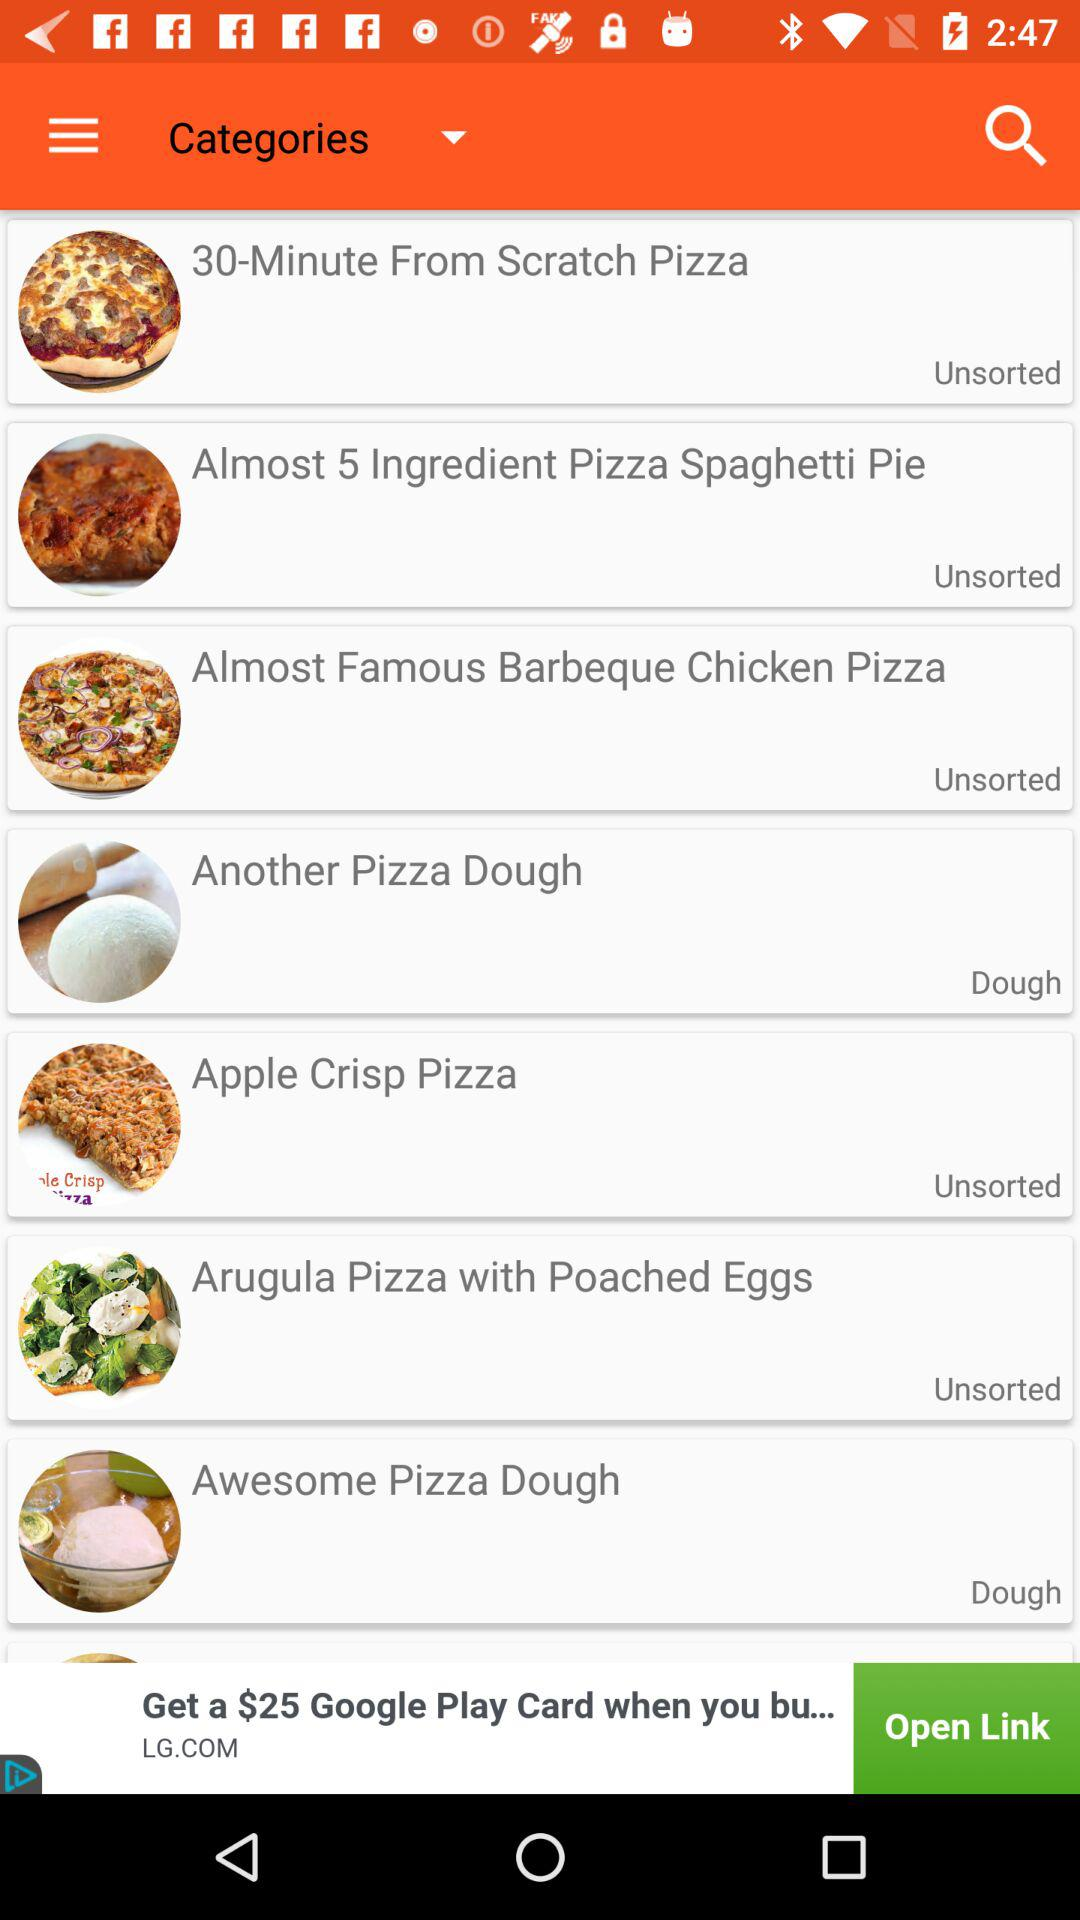Which category does "Another Pizza Dough" belong to? It belongs to "Dough" category. 